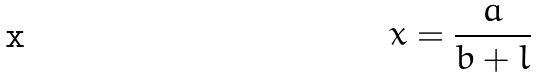Convert formula to latex. <formula><loc_0><loc_0><loc_500><loc_500>x = \frac { a } { b + l }</formula> 